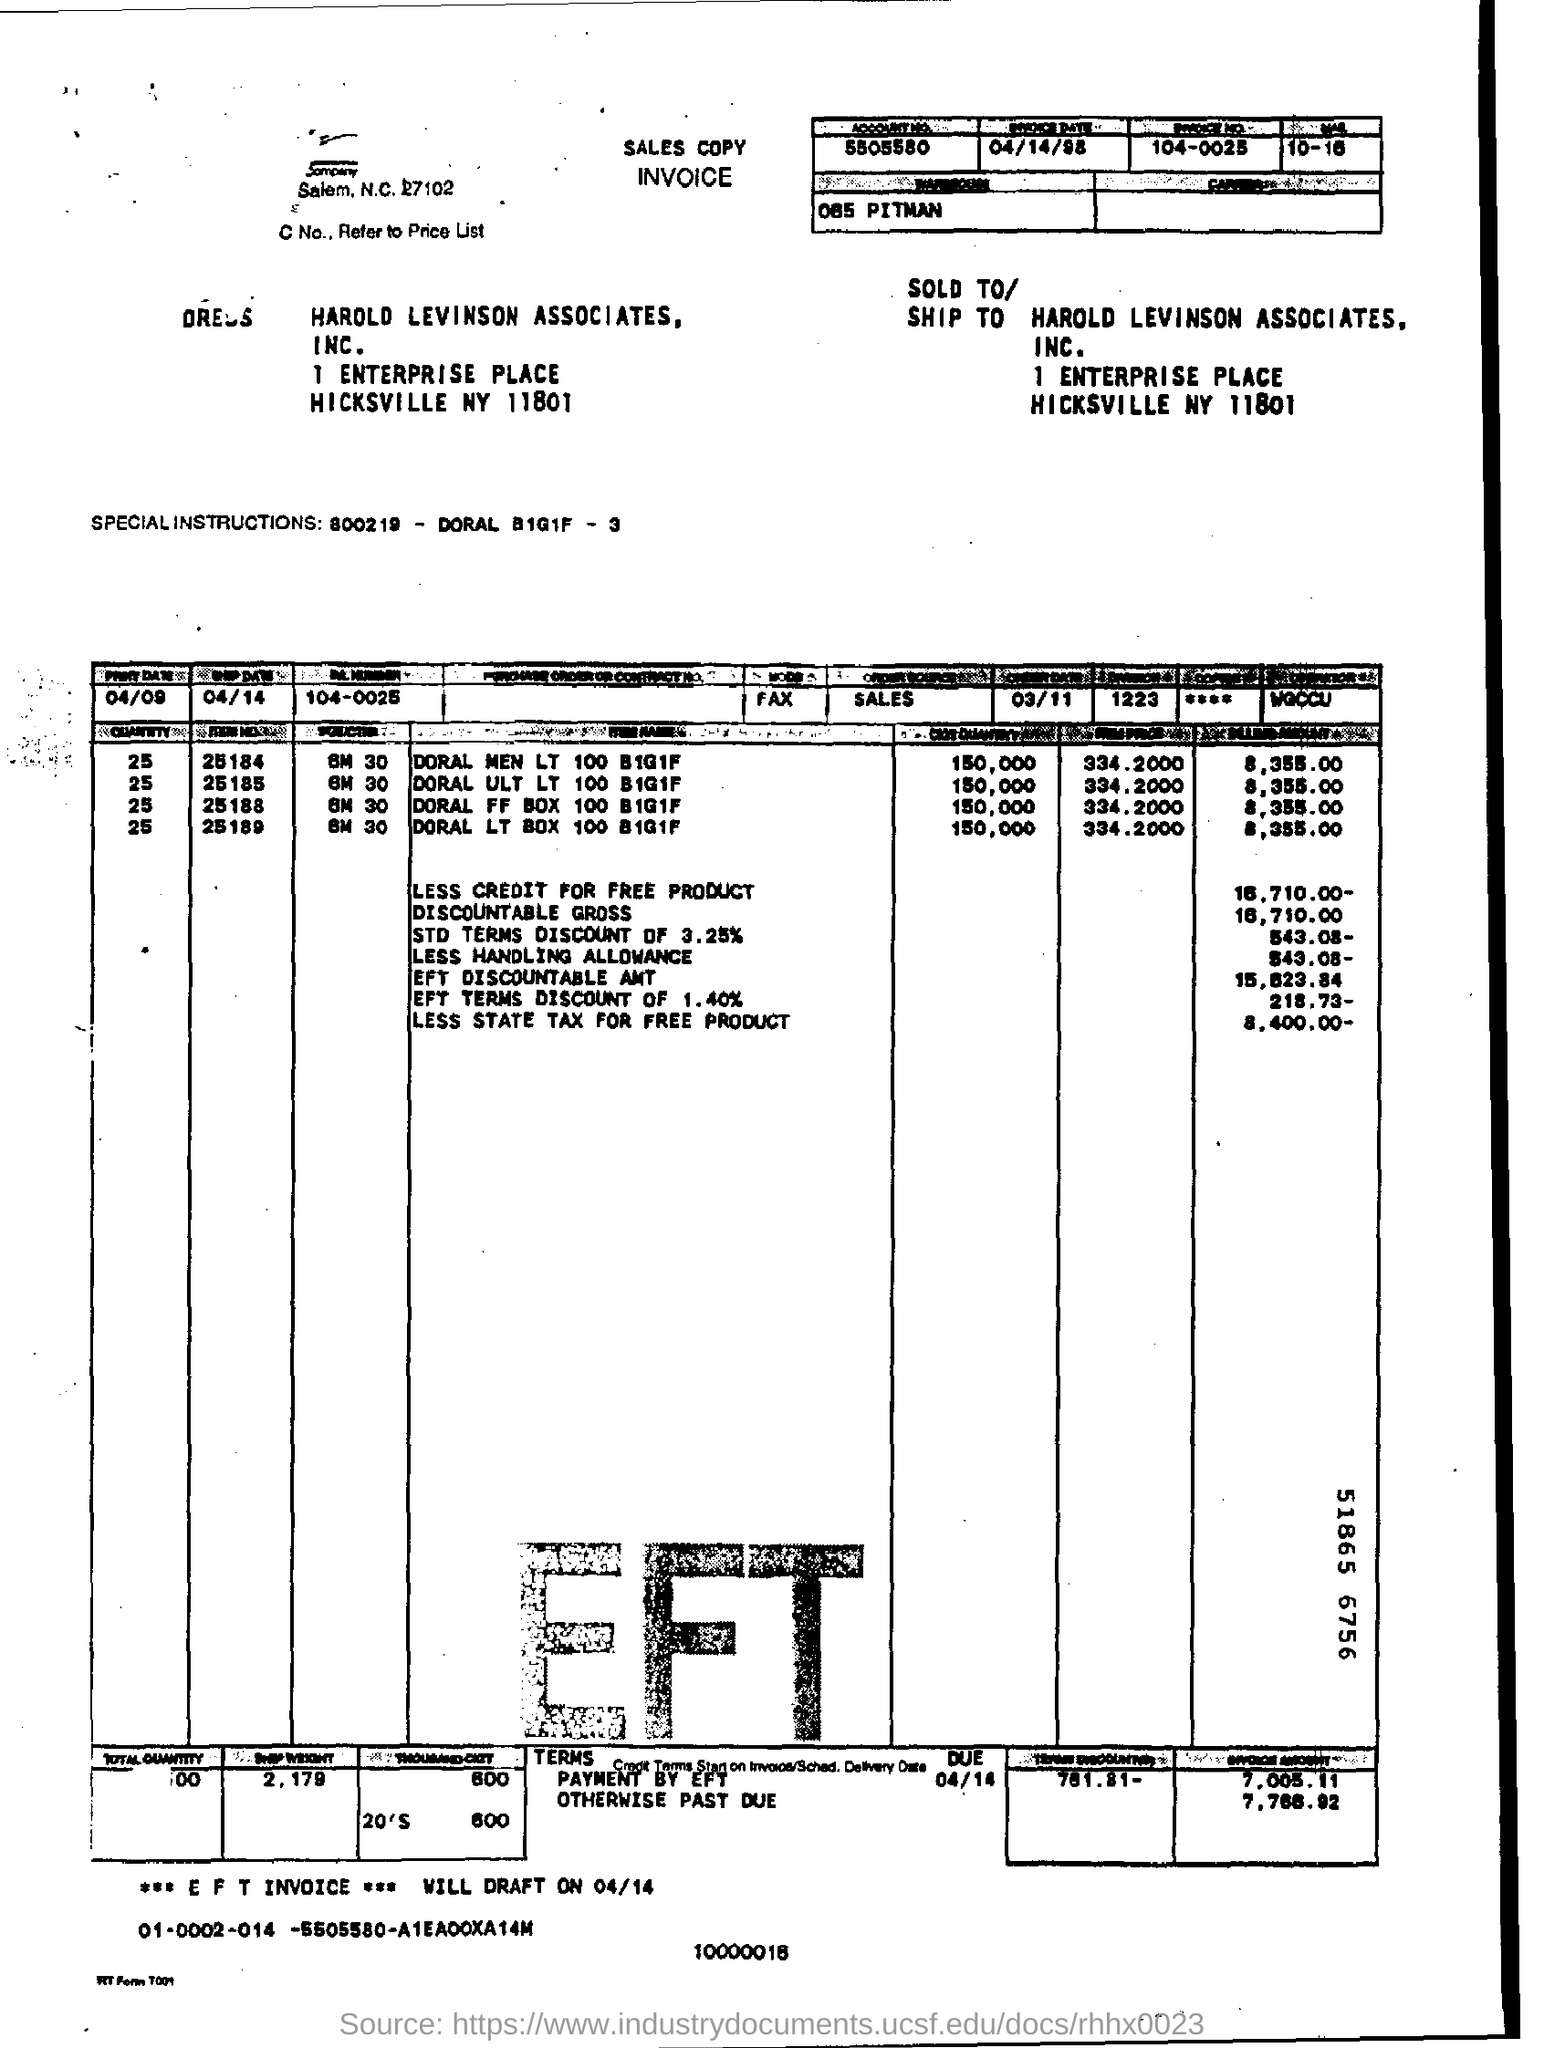What is the account no?
Offer a very short reply. 5505580. What is the invoice date?
Provide a short and direct response. 04/14/98. 